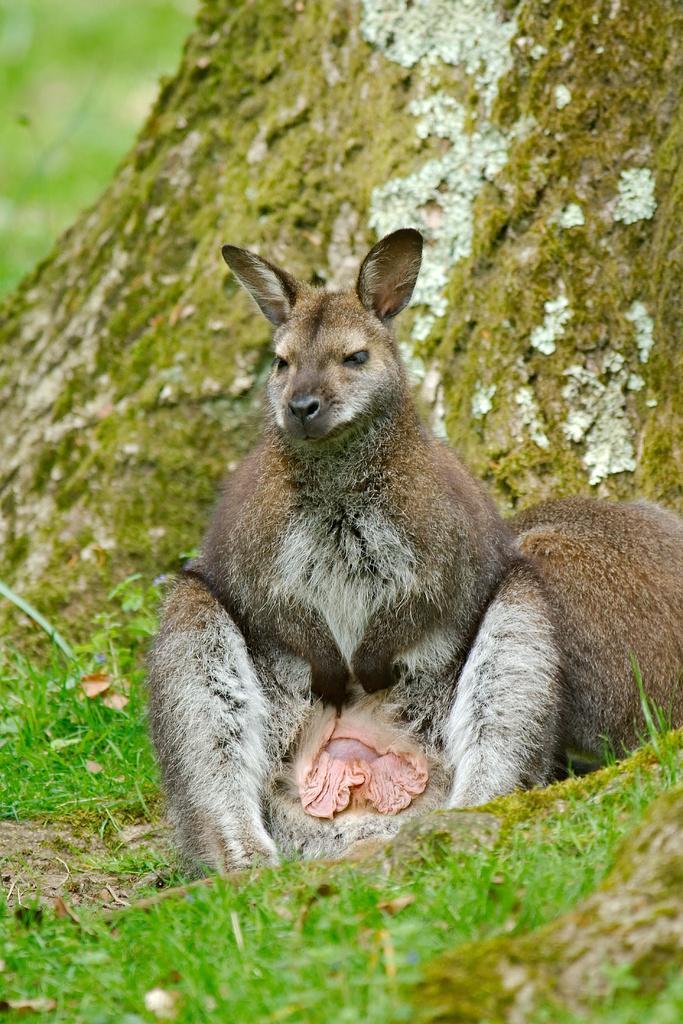In one or two sentences, can you explain what this image depicts? In the center of an image we can see an animal. We can also see some grass and the bark of a tree. 